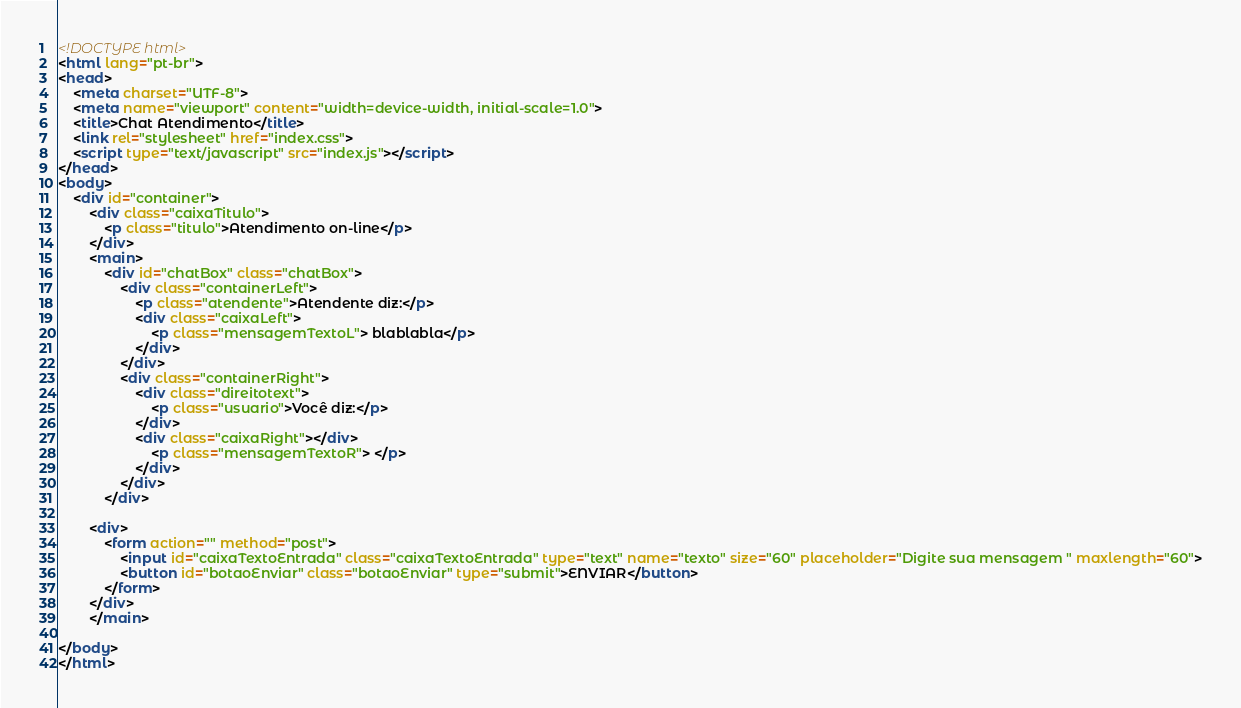Convert code to text. <code><loc_0><loc_0><loc_500><loc_500><_HTML_><!DOCTYPE html>
<html lang="pt-br">
<head>
    <meta charset="UTF-8">
    <meta name="viewport" content="width=device-width, initial-scale=1.0">
    <title>Chat Atendimento</title>
    <link rel="stylesheet" href="index.css">
    <script type="text/javascript" src="index.js"></script>
</head>
<body>
    <div id="container">
        <div class="caixaTitulo">
            <p class="titulo">Atendimento on-line</p>
        </div>
        <main>
            <div id="chatBox" class="chatBox">
                <div class="containerLeft">                                   
                    <p class="atendente">Atendente diz:</p>
                    <div class="caixaLeft">
                        <p class="mensagemTextoL"> blablabla</p>
                    </div>                  
                </div>
                <div class="containerRight">                            
                    <div class="direitotext">
                        <p class="usuario">Você diz:</p>
                    </div>   
                    <div class="caixaRight"></div>
                        <p class="mensagemTextoR"> </p>
                    </div>                  
                </div>
            </div>
        
        <div>
            <form action="" method="post">               
                <input id="caixaTextoEntrada" class="caixaTextoEntrada" type="text" name="texto" size="60" placeholder="Digite sua mensagem " maxlength="60">
                <button id="botaoEnviar" class="botaoEnviar" type="submit">ENVIAR</button>
            </form>    
        </div>
        </main>
        
</body>
</html></code> 